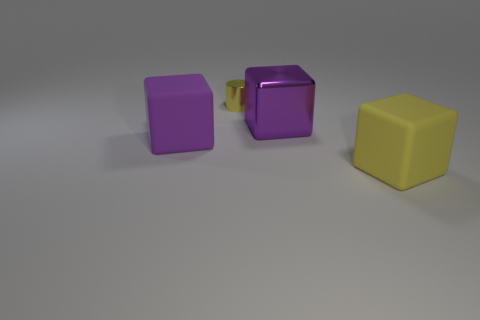Subtract all large purple cubes. How many cubes are left? 1 Add 1 large purple blocks. How many objects exist? 5 Subtract all purple blocks. How many blocks are left? 1 Subtract all cubes. How many objects are left? 1 Subtract all cyan cylinders. How many yellow blocks are left? 1 Add 1 yellow rubber objects. How many yellow rubber objects are left? 2 Add 3 big cubes. How many big cubes exist? 6 Subtract 0 purple spheres. How many objects are left? 4 Subtract 3 blocks. How many blocks are left? 0 Subtract all gray cylinders. Subtract all gray balls. How many cylinders are left? 1 